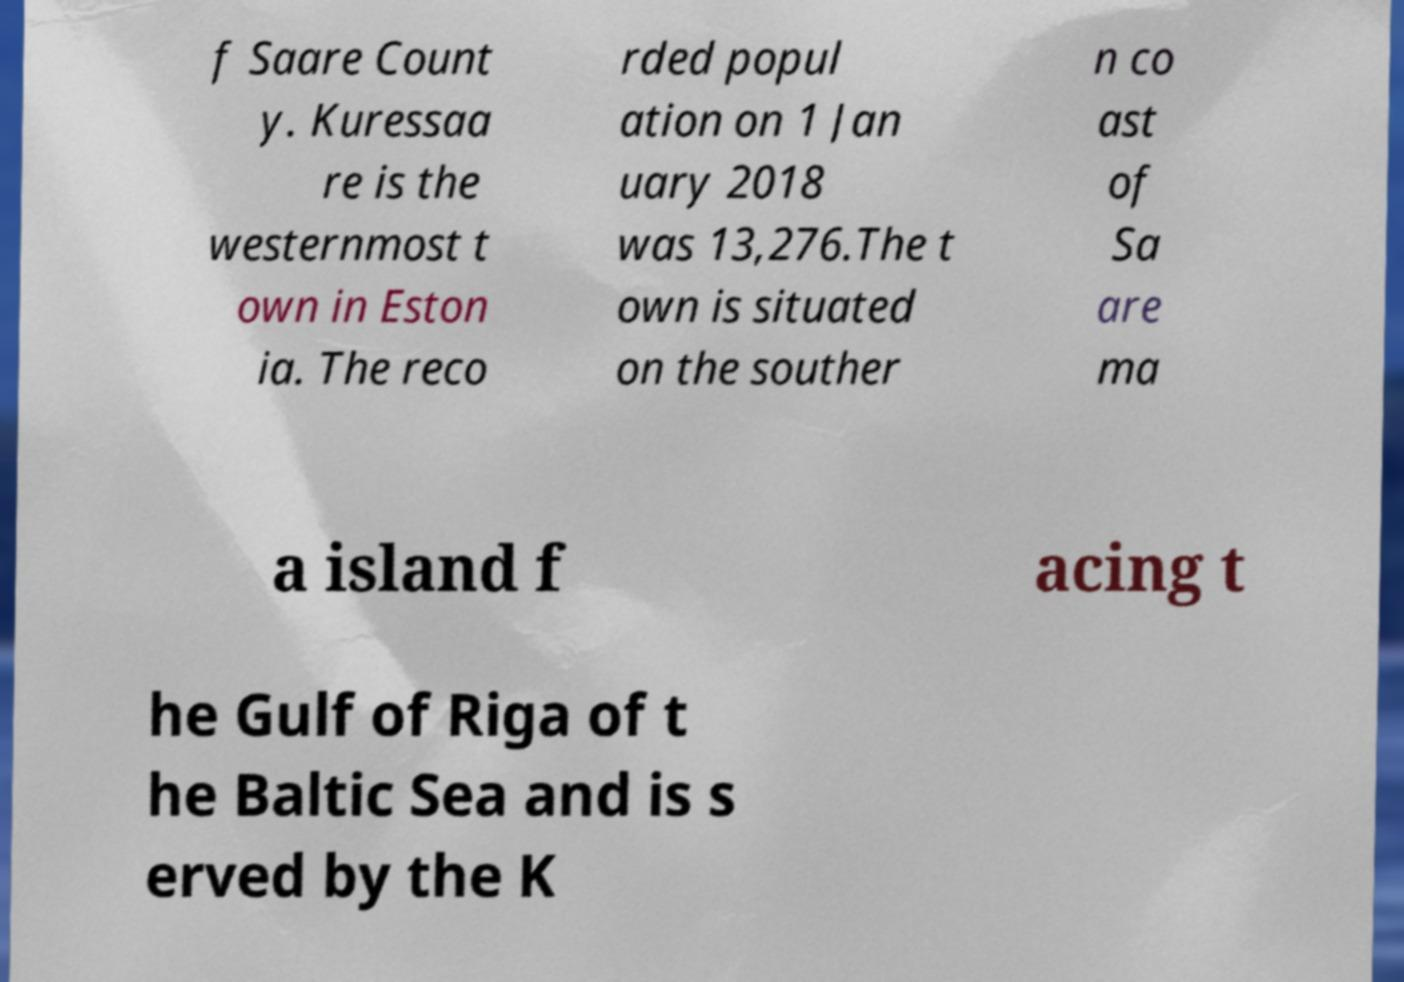Can you read and provide the text displayed in the image?This photo seems to have some interesting text. Can you extract and type it out for me? f Saare Count y. Kuressaa re is the westernmost t own in Eston ia. The reco rded popul ation on 1 Jan uary 2018 was 13,276.The t own is situated on the souther n co ast of Sa are ma a island f acing t he Gulf of Riga of t he Baltic Sea and is s erved by the K 